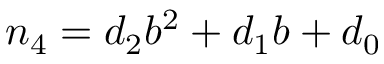Convert formula to latex. <formula><loc_0><loc_0><loc_500><loc_500>n _ { 4 } = d _ { 2 } b ^ { 2 } + d _ { 1 } b + d _ { 0 }</formula> 